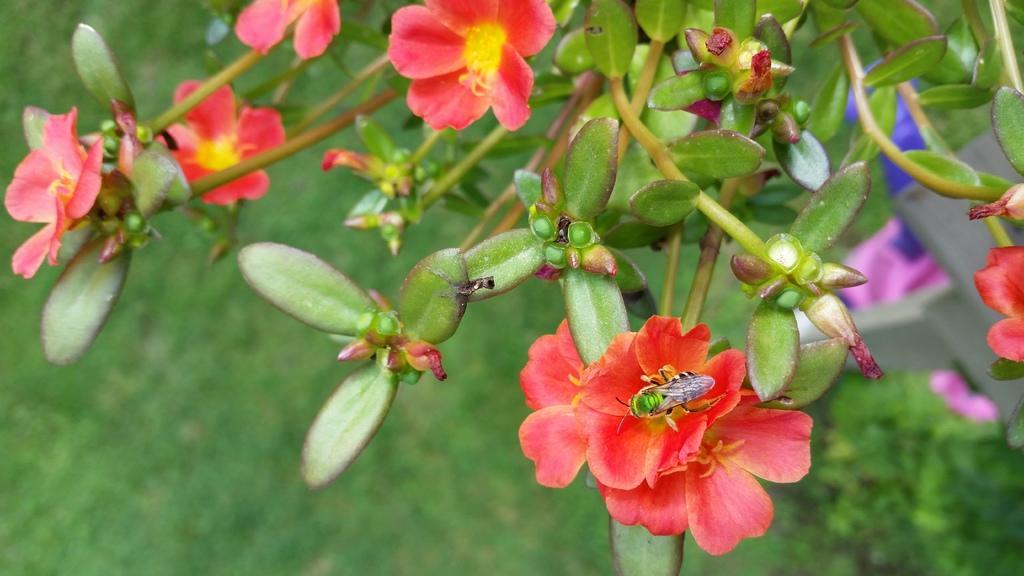In one or two sentences, can you explain what this image depicts? In this image we can see some flowers, buds, insect, also we can see plants, and the background is blurred. 